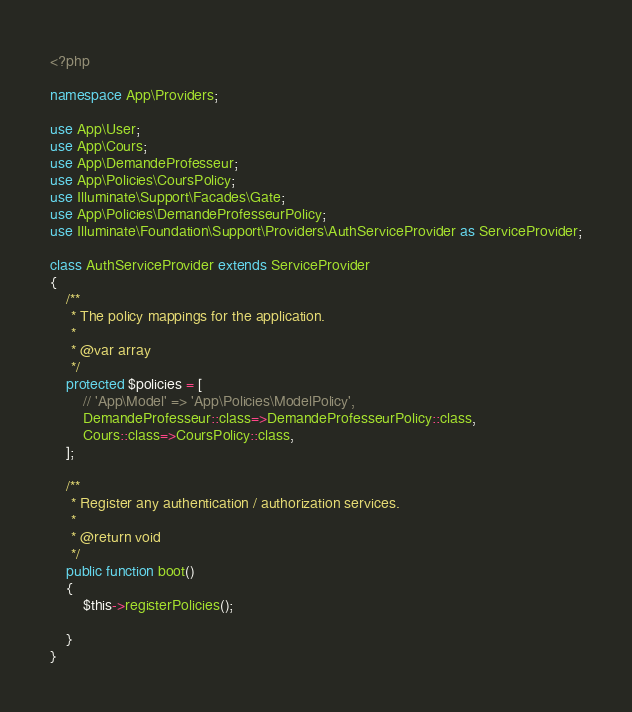Convert code to text. <code><loc_0><loc_0><loc_500><loc_500><_PHP_><?php

namespace App\Providers;

use App\User;
use App\Cours;
use App\DemandeProfesseur;
use App\Policies\CoursPolicy;
use Illuminate\Support\Facades\Gate;
use App\Policies\DemandeProfesseurPolicy;
use Illuminate\Foundation\Support\Providers\AuthServiceProvider as ServiceProvider;

class AuthServiceProvider extends ServiceProvider
{
    /**
     * The policy mappings for the application.
     *
     * @var array
     */
    protected $policies = [
        // 'App\Model' => 'App\Policies\ModelPolicy',
        DemandeProfesseur::class=>DemandeProfesseurPolicy::class,
        Cours::class=>CoursPolicy::class,
    ];

    /**
     * Register any authentication / authorization services.
     *
     * @return void
     */
    public function boot()
    {
        $this->registerPolicies();

    }
}
</code> 